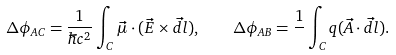<formula> <loc_0><loc_0><loc_500><loc_500>\Delta \phi _ { A C } = \frac { 1 } { \hbar { c } ^ { 2 } } \int _ { C } \vec { \mu } \cdot ( \vec { E } \times \vec { d l } ) , \quad \Delta \phi _ { A B } = \frac { 1 } { } \int _ { C } q ( \vec { A } \cdot \vec { d l } ) .</formula> 